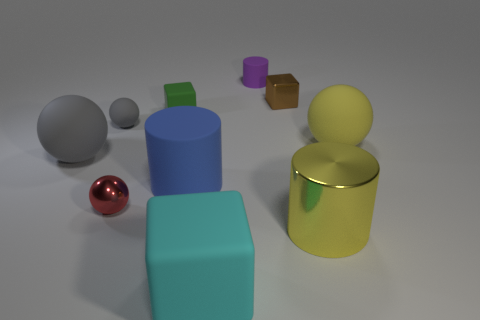Do the big sphere that is to the right of the small gray sphere and the shiny thing in front of the small red metallic sphere have the same color?
Your answer should be very brief. Yes. There is a large thing that is both right of the small matte cylinder and in front of the red ball; what is its shape?
Give a very brief answer. Cylinder. There is a large cylinder that is the same material as the small red sphere; what is its color?
Offer a very short reply. Yellow. What shape is the shiny thing on the left side of the brown metallic thing behind the big yellow thing that is in front of the metallic sphere?
Offer a terse response. Sphere. What size is the brown thing?
Offer a terse response. Small. What shape is the red object that is made of the same material as the brown cube?
Provide a short and direct response. Sphere. Is the number of blue objects that are on the left side of the large blue object less than the number of matte things?
Offer a very short reply. Yes. There is a small shiny object on the left side of the tiny purple object; what is its color?
Your answer should be compact. Red. Are there any tiny green rubber objects of the same shape as the brown metallic thing?
Offer a terse response. Yes. How many small green rubber things are the same shape as the big metallic thing?
Make the answer very short. 0. 